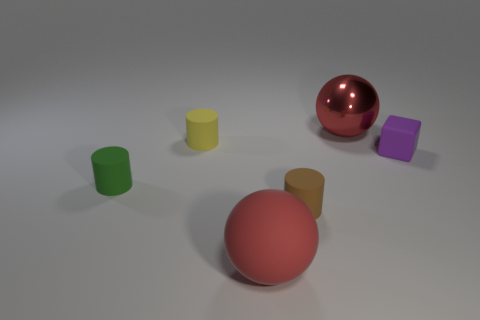Add 2 brown matte objects. How many objects exist? 8 Subtract all tiny brown rubber cylinders. How many cylinders are left? 2 Subtract 1 spheres. How many spheres are left? 1 Subtract all brown cylinders. How many cylinders are left? 2 Add 2 red spheres. How many red spheres are left? 4 Add 2 purple cubes. How many purple cubes exist? 3 Subtract 0 purple spheres. How many objects are left? 6 Subtract all spheres. How many objects are left? 4 Subtract all purple balls. Subtract all red cylinders. How many balls are left? 2 Subtract all red blocks. How many brown balls are left? 0 